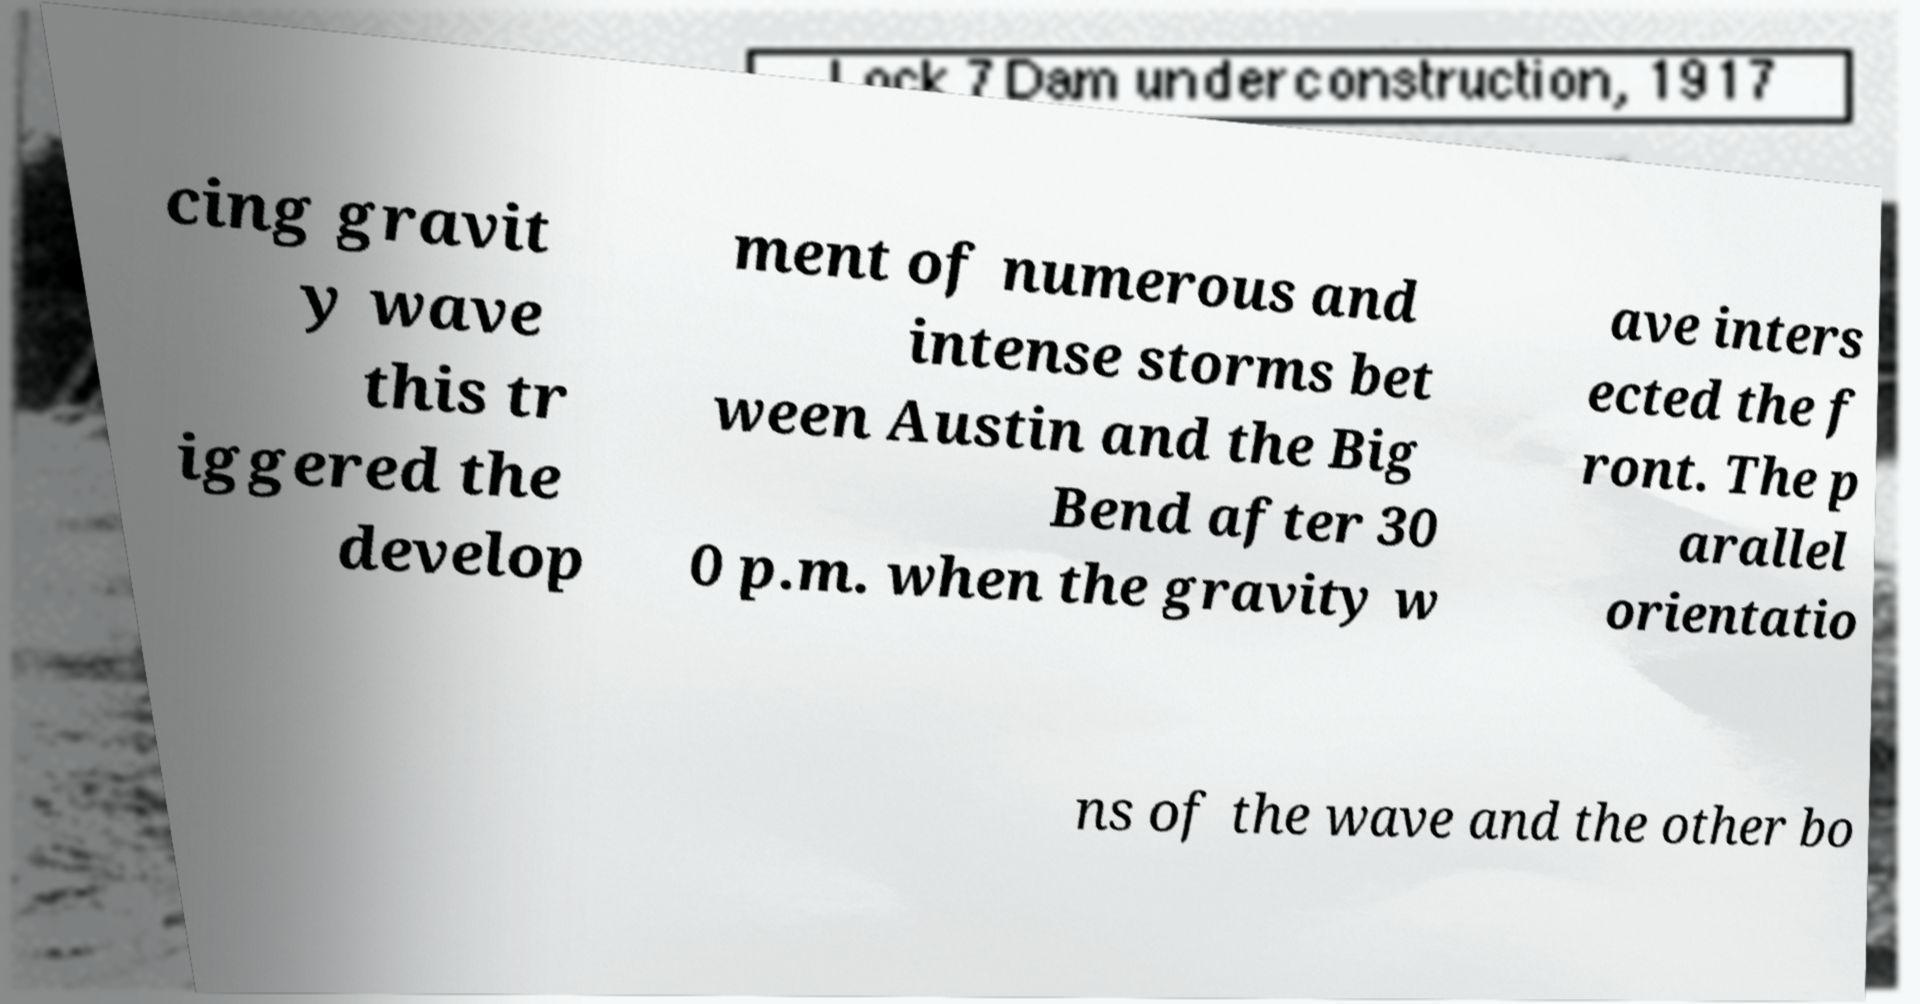What messages or text are displayed in this image? I need them in a readable, typed format. cing gravit y wave this tr iggered the develop ment of numerous and intense storms bet ween Austin and the Big Bend after 30 0 p.m. when the gravity w ave inters ected the f ront. The p arallel orientatio ns of the wave and the other bo 